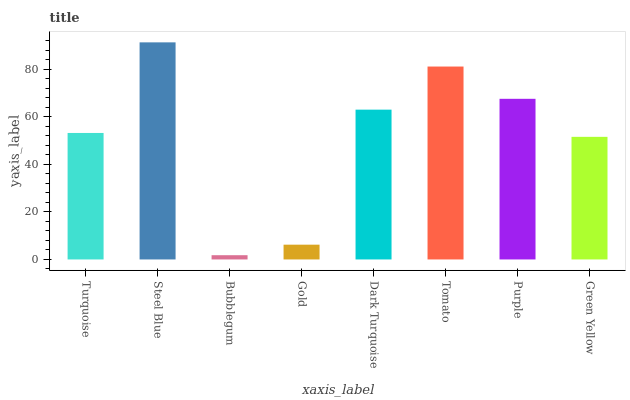Is Bubblegum the minimum?
Answer yes or no. Yes. Is Steel Blue the maximum?
Answer yes or no. Yes. Is Steel Blue the minimum?
Answer yes or no. No. Is Bubblegum the maximum?
Answer yes or no. No. Is Steel Blue greater than Bubblegum?
Answer yes or no. Yes. Is Bubblegum less than Steel Blue?
Answer yes or no. Yes. Is Bubblegum greater than Steel Blue?
Answer yes or no. No. Is Steel Blue less than Bubblegum?
Answer yes or no. No. Is Dark Turquoise the high median?
Answer yes or no. Yes. Is Turquoise the low median?
Answer yes or no. Yes. Is Steel Blue the high median?
Answer yes or no. No. Is Tomato the low median?
Answer yes or no. No. 